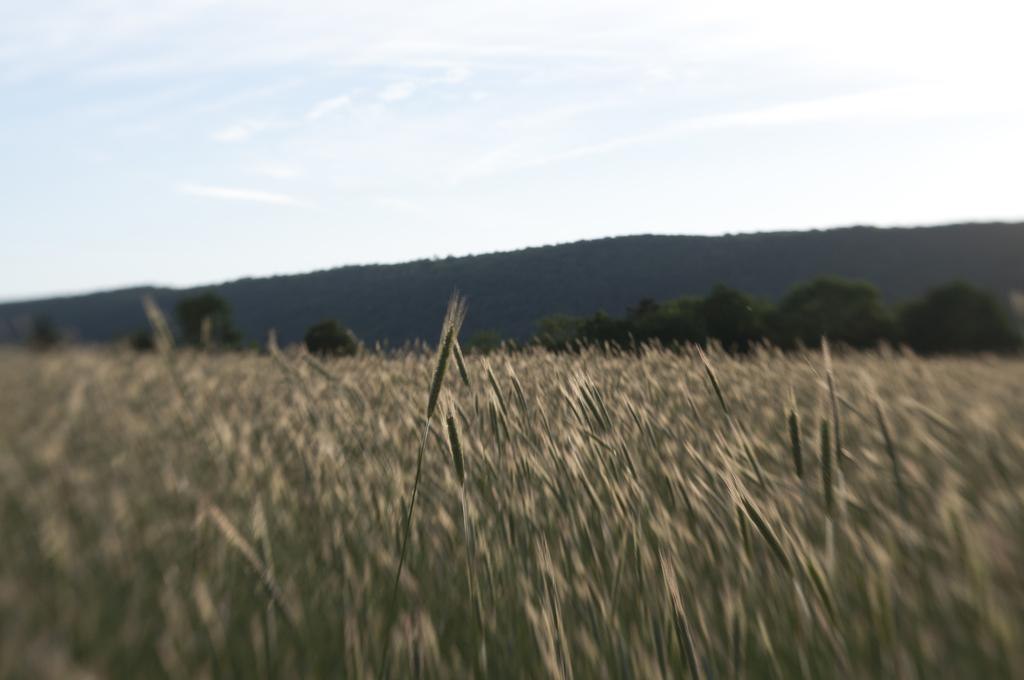What is located in the foreground of the image? There is a crop in the foreground of the image. What can be seen in the background of the image? There are trees, mountains, and the sky visible in the background of the image. What type of hope can be seen growing in the image? There is no hope present in the image; it features a crop, trees, mountains, and the sky. What type of plough is being used to cultivate the crop in the image? There is no plough visible in the image; it only shows a crop in the foreground. 